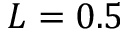<formula> <loc_0><loc_0><loc_500><loc_500>L = 0 . 5</formula> 